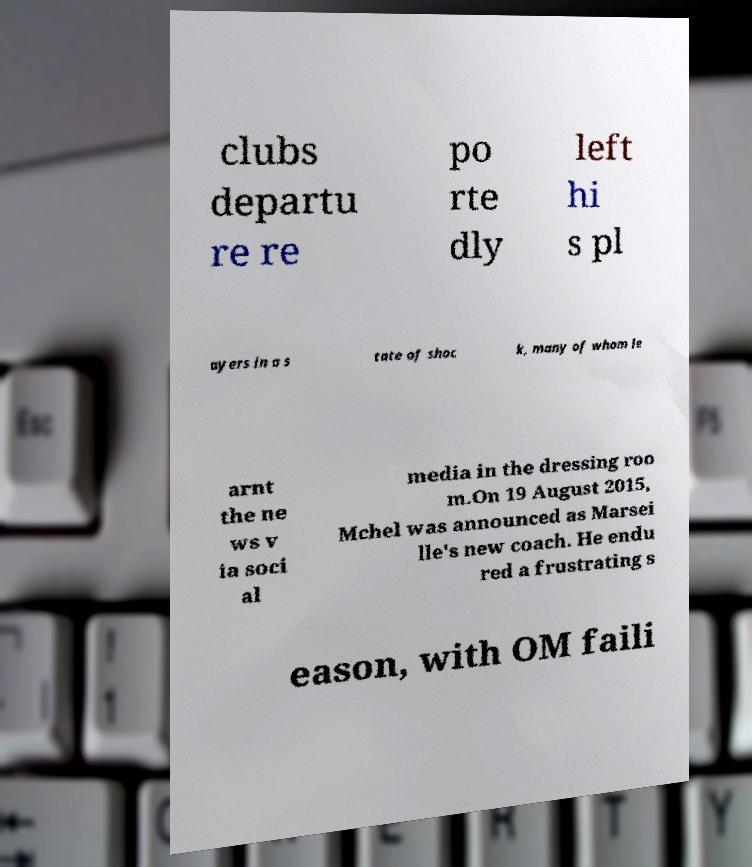Can you accurately transcribe the text from the provided image for me? clubs departu re re po rte dly left hi s pl ayers in a s tate of shoc k, many of whom le arnt the ne ws v ia soci al media in the dressing roo m.On 19 August 2015, Mchel was announced as Marsei lle's new coach. He endu red a frustrating s eason, with OM faili 